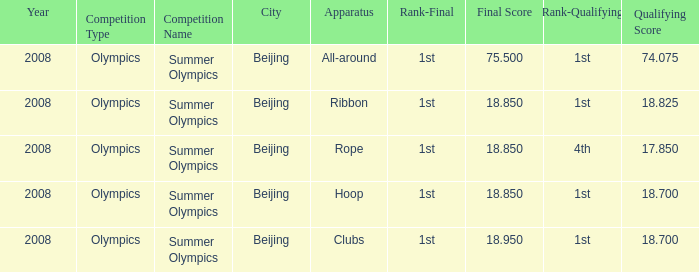What was her final score on the ribbon apparatus? 18.85. 